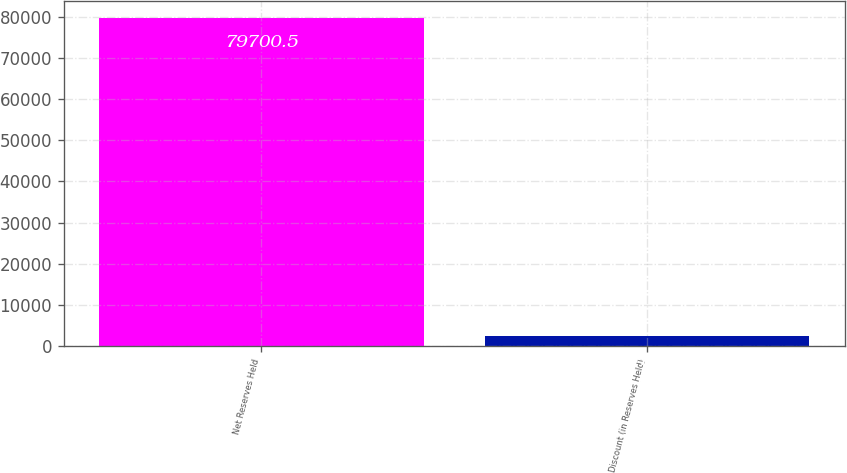<chart> <loc_0><loc_0><loc_500><loc_500><bar_chart><fcel>Net Reserves Held<fcel>Discount (in Reserves Held)<nl><fcel>79700.5<fcel>2574<nl></chart> 